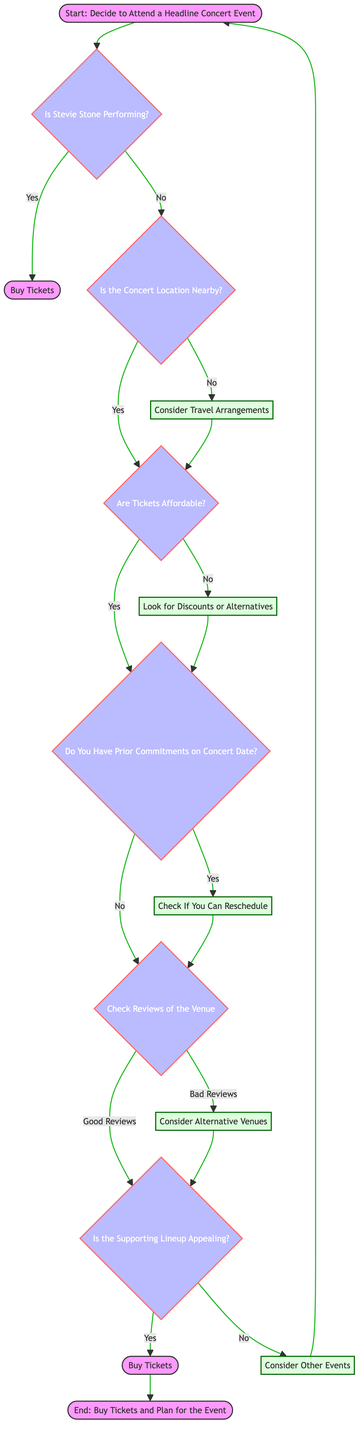What is the first question asked in the flow chart? The first question in the flow chart is located after the "Start: Decide to Attend a Headline Concert Event" node. It is explicitly stated as "Is Stevie Stone Performing?"
Answer: Is Stevie Stone Performing? How many main decision nodes are there in the flow chart? The flow chart consists of several decision nodes where the questions are asked. Counting them, we have six main decision nodes: "Is Stevie Stone Performing?", "Is the Concert Location Nearby?", "Are Tickets Affordable?", "Do You Have Prior Commitments on Concert Date?", "Check Reviews of the Venue", and "Is the Supporting Lineup Appealing?".
Answer: 6 If tickets are not affordable, what should one look for? The flow chart indicates that if tickets are not affordable, the next step is to "Look for Discounts or Alternatives." This connects the "Are Tickets Affordable?" decision to the next action.
Answer: Look for Discounts or Alternatives What happens if the venue has bad reviews? According to the flow chart, if the venue has bad reviews after checking reviews, the next step is to "Consider Alternative Venues." This prevents proceeding further without satisfactory venue reviews.
Answer: Consider Alternative Venues What do you do if Stevie Stone is performing? The flow chart shows that if the answer to "Is Stevie Stone Performing?" is Yes, then the action taken is to "Buy Tickets" immediately. This indicates a direct progression to purchasing tickets for the concert.
Answer: Buy Tickets If you have prior commitments on concert date, what should you check? The diagram indicates that if the response to "Do You Have Prior Commitments on Concert Date?" is Yes, the next step is to "Check If You Can Reschedule." This ensures that attendees consider their schedule before making a purchase.
Answer: Check If You Can Reschedule What is the end goal of attending a headline concert event as depicted in the flow chart? The end goal in the flow chart is labeled as "Buy Tickets and Plan for the Event." This signifies the final outcome once all conditions and decisions have been satisfied.
Answer: Buy Tickets and Plan for the Event 